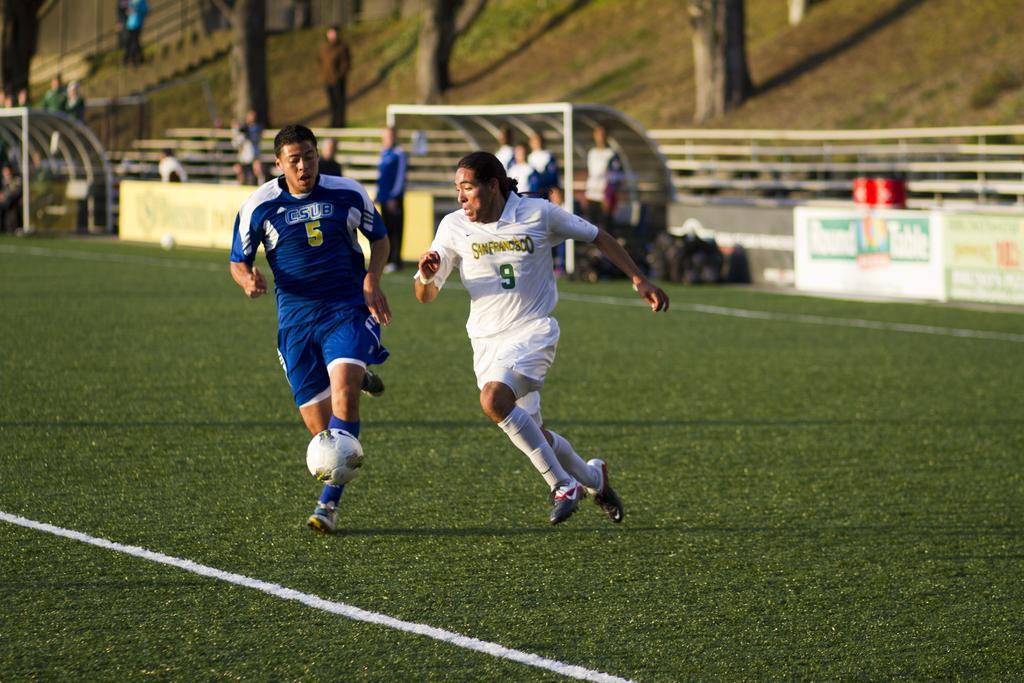How would you summarize this image in a sentence or two? In this picture we can see two men playing a football in a playground. On the background we can see few persons standing. This is a grass. These are branches of trees. Here we can see hoardings. This is a fence. 